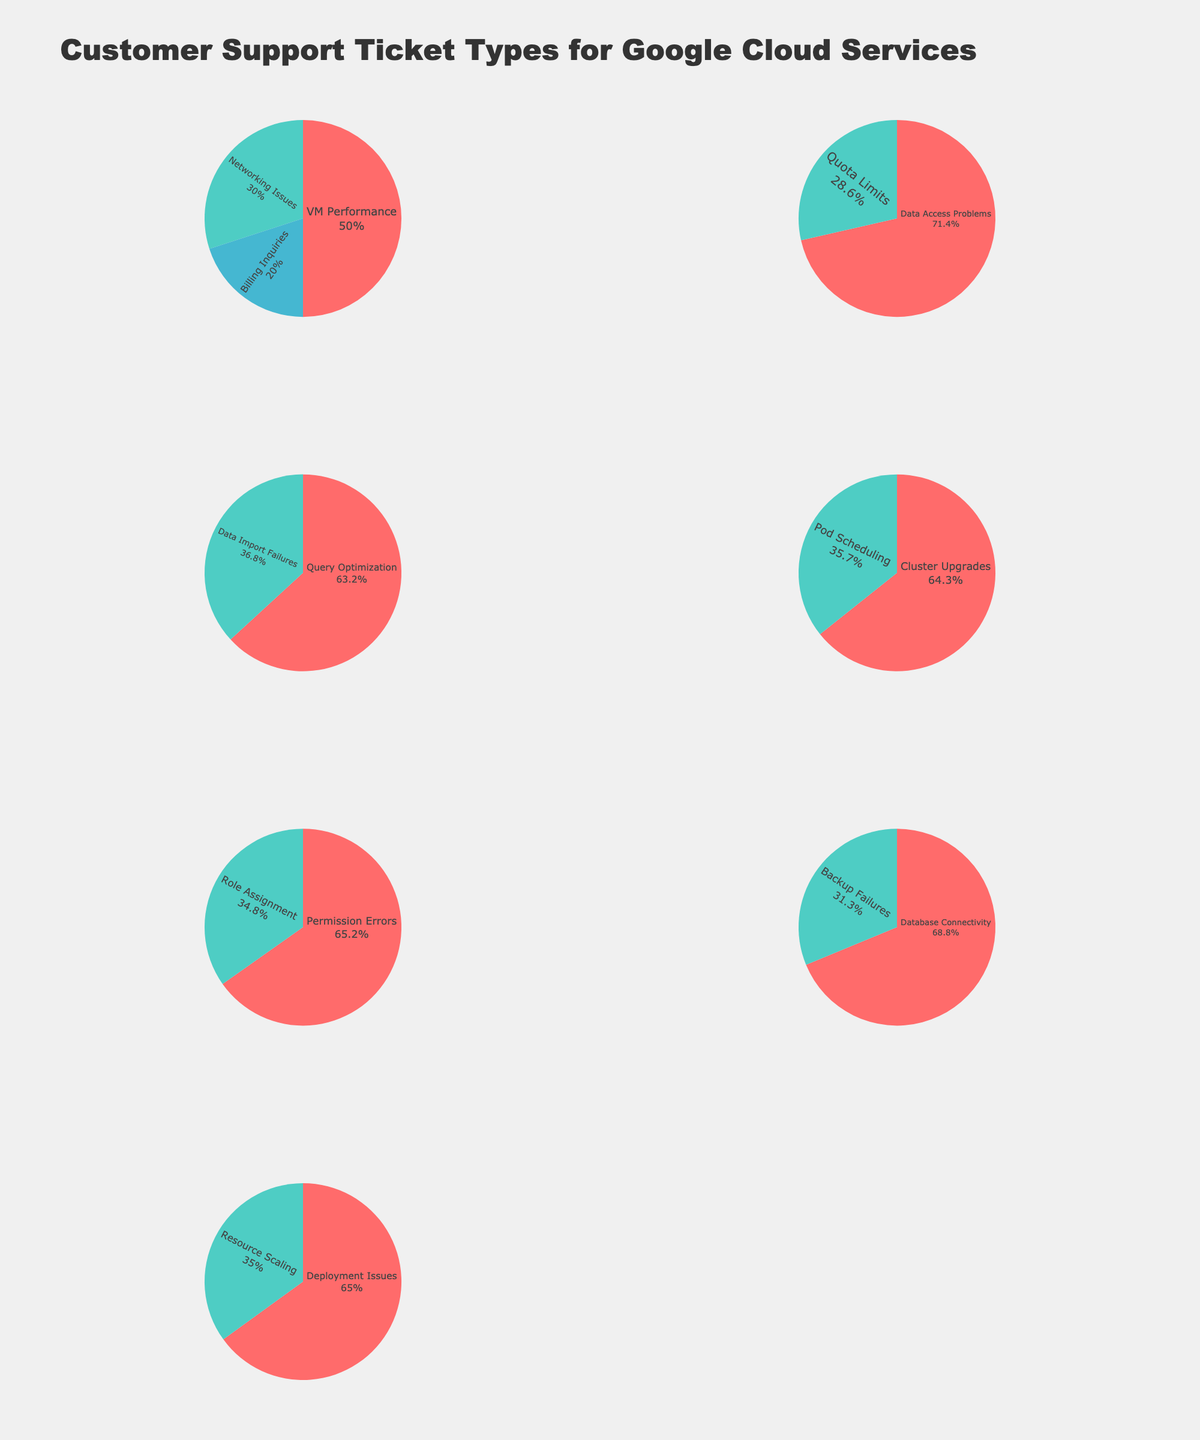what is the title of the figure? The title is located at the top of the figure and states the main topic of the visual data. Here, it reads "Customer Support Ticket Types for Google Cloud Services."
Answer: Customer Support Ticket Types for Google Cloud Services what service has the highest percentage of support tickets for VM performance issues? The slice representing VM Performance issues shows it is a part of Compute Engine service. The percentage for VM Performance under Compute Engine is 25%, the highest for VM performance issues.
Answer: Compute Engine which issue category under Cloud Storage has the largest percentage of support tickets? By looking at the pie chart for Cloud Storage, the Data Access Problems slice is the largest. The percentage for Data Access Problems is shown as 20%.
Answer: Data Access Problems compare the percentages of Networking Issues and Data Access Problems. Which one is greater? Networking Issues fall under Compute Engine with a percentage of 15%, and Data Access Problems fall under Cloud Storage with a percentage of 20%. By comparing numerically, 20% is greater than 15%.
Answer: Data Access Problems what is the total percentage of support tickets for Kubernetes Engine? The Kubernetes Engine pie chart shows percentages for Cluster Upgrades (18%) and Pod Scheduling (10%). Adding these gives 18% + 10% = 28%.
Answer: 28% which service has more ticket types with a percentage less than 10%? By examining each pie chart individually, Cloud IAM has two categories under 10%: Role Assignment (8%) and Permission Errors (15%). In contrast, others have fewer or none under 10%.
Answer: Cloud IAM how many support issues are presented for App Engine? By looking at the pie chart titled App Engine, you can see two distinct slices: Deployment Issues and Resource Scaling. This indicates two support issues for App Engine.
Answer: 2 what percentage of tickets are related to Cluster Upgrades in Kubernetes Engine? Identify the Cluster Upgrades slice within the Kubernetes Engine pie chart. The percentage is directly indicated as 18%.
Answer: 18% what is the combined percentage of tickets for Billing Inquiries and Query Optimization? Billing Inquiries under Compute Engine is 10% and Query Optimization under BigQuery is 12%. Adding these together gives 10% + 12% = 22%.
Answer: 22% between Cloud SQL and App Engine, which has a higher individual issue percentage exceeding 20%? Cloud SQL has Database Connectivity Issues at 22%. App Engine does not have any issue category exceeding 20%, making Cloud SQL the answer.
Answer: Cloud SQL 